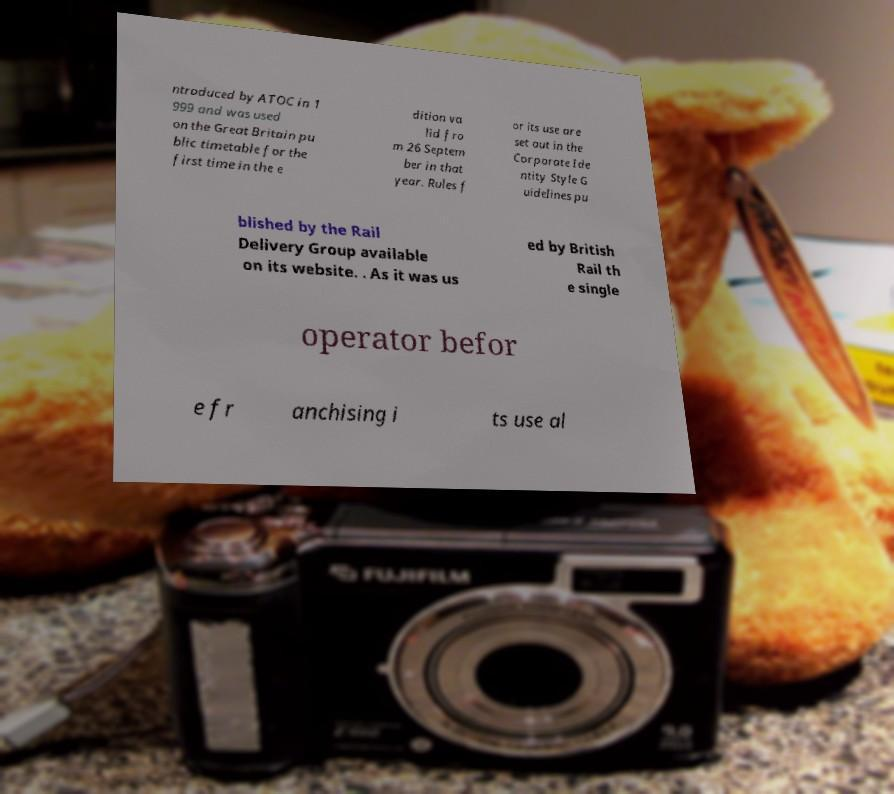Could you assist in decoding the text presented in this image and type it out clearly? ntroduced by ATOC in 1 999 and was used on the Great Britain pu blic timetable for the first time in the e dition va lid fro m 26 Septem ber in that year. Rules f or its use are set out in the Corporate Ide ntity Style G uidelines pu blished by the Rail Delivery Group available on its website. . As it was us ed by British Rail th e single operator befor e fr anchising i ts use al 